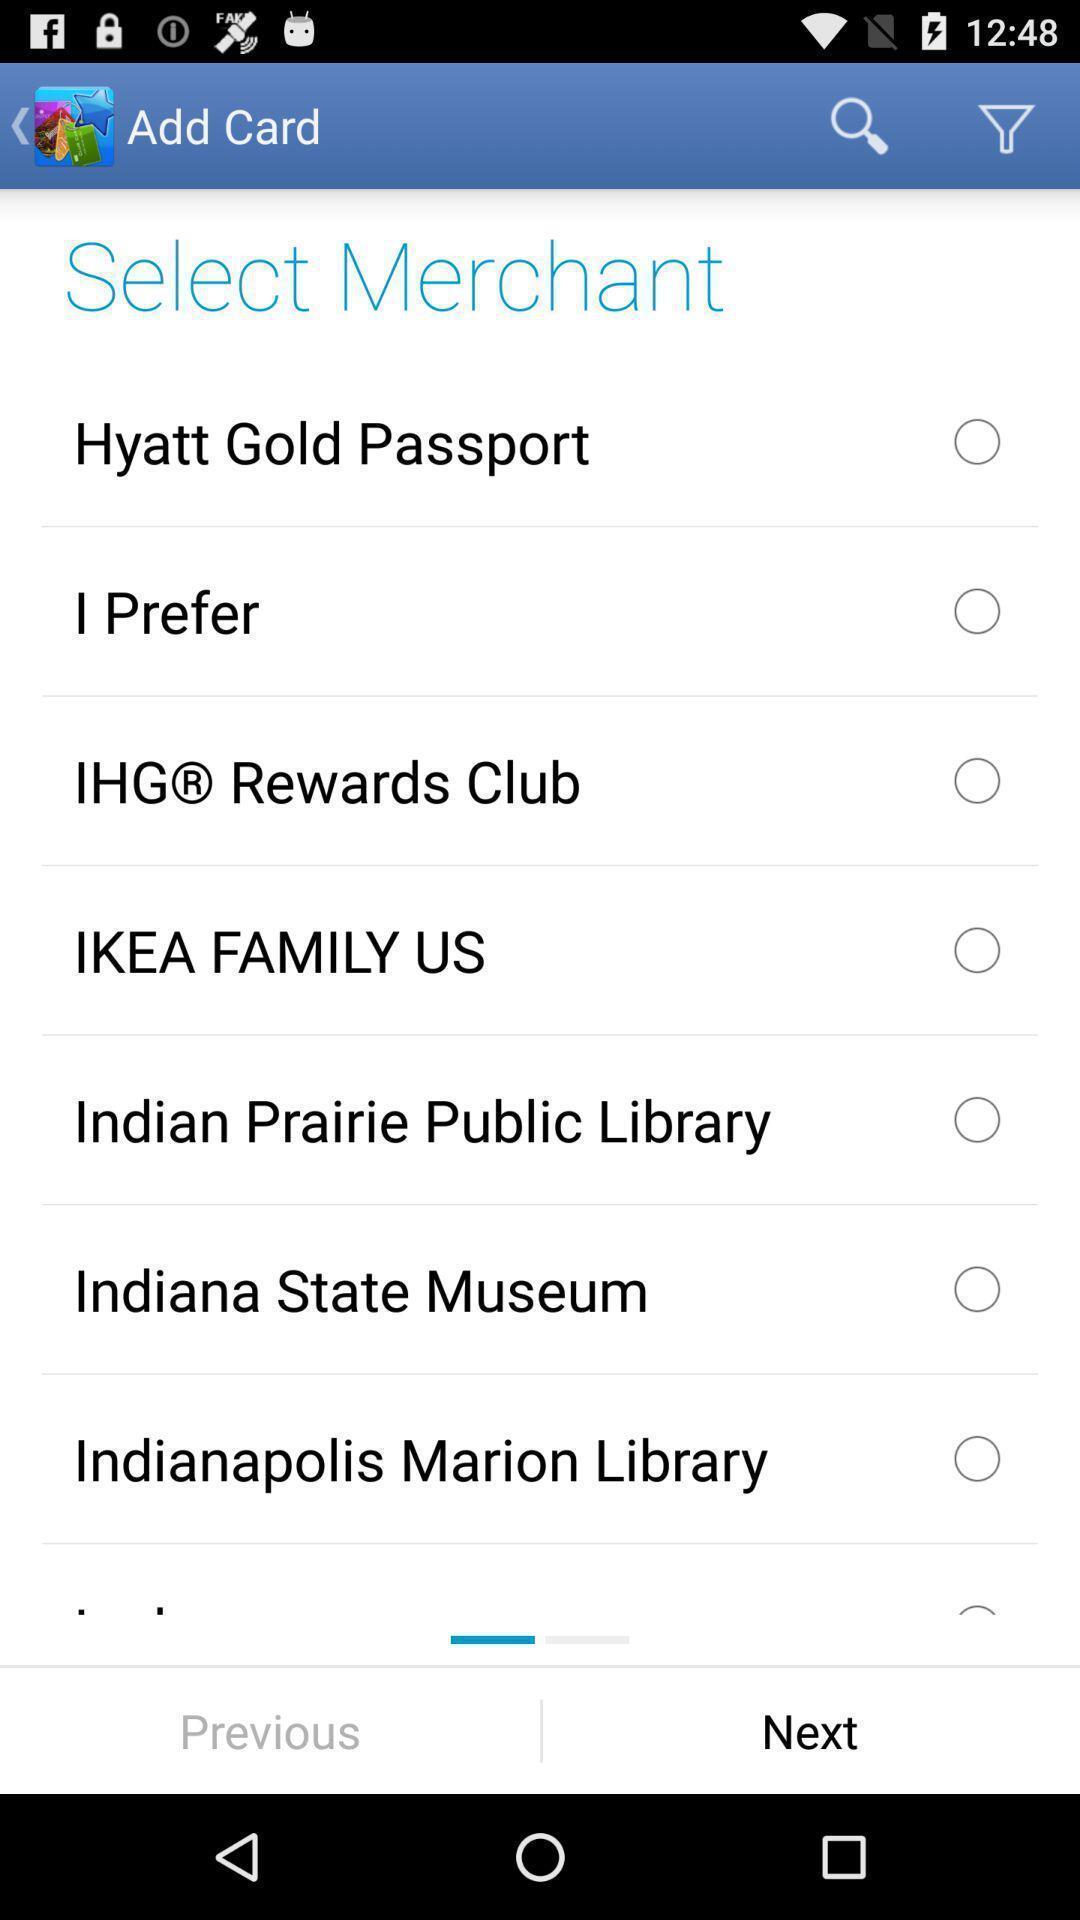Please provide a description for this image. Screen showing list of various merchants. 